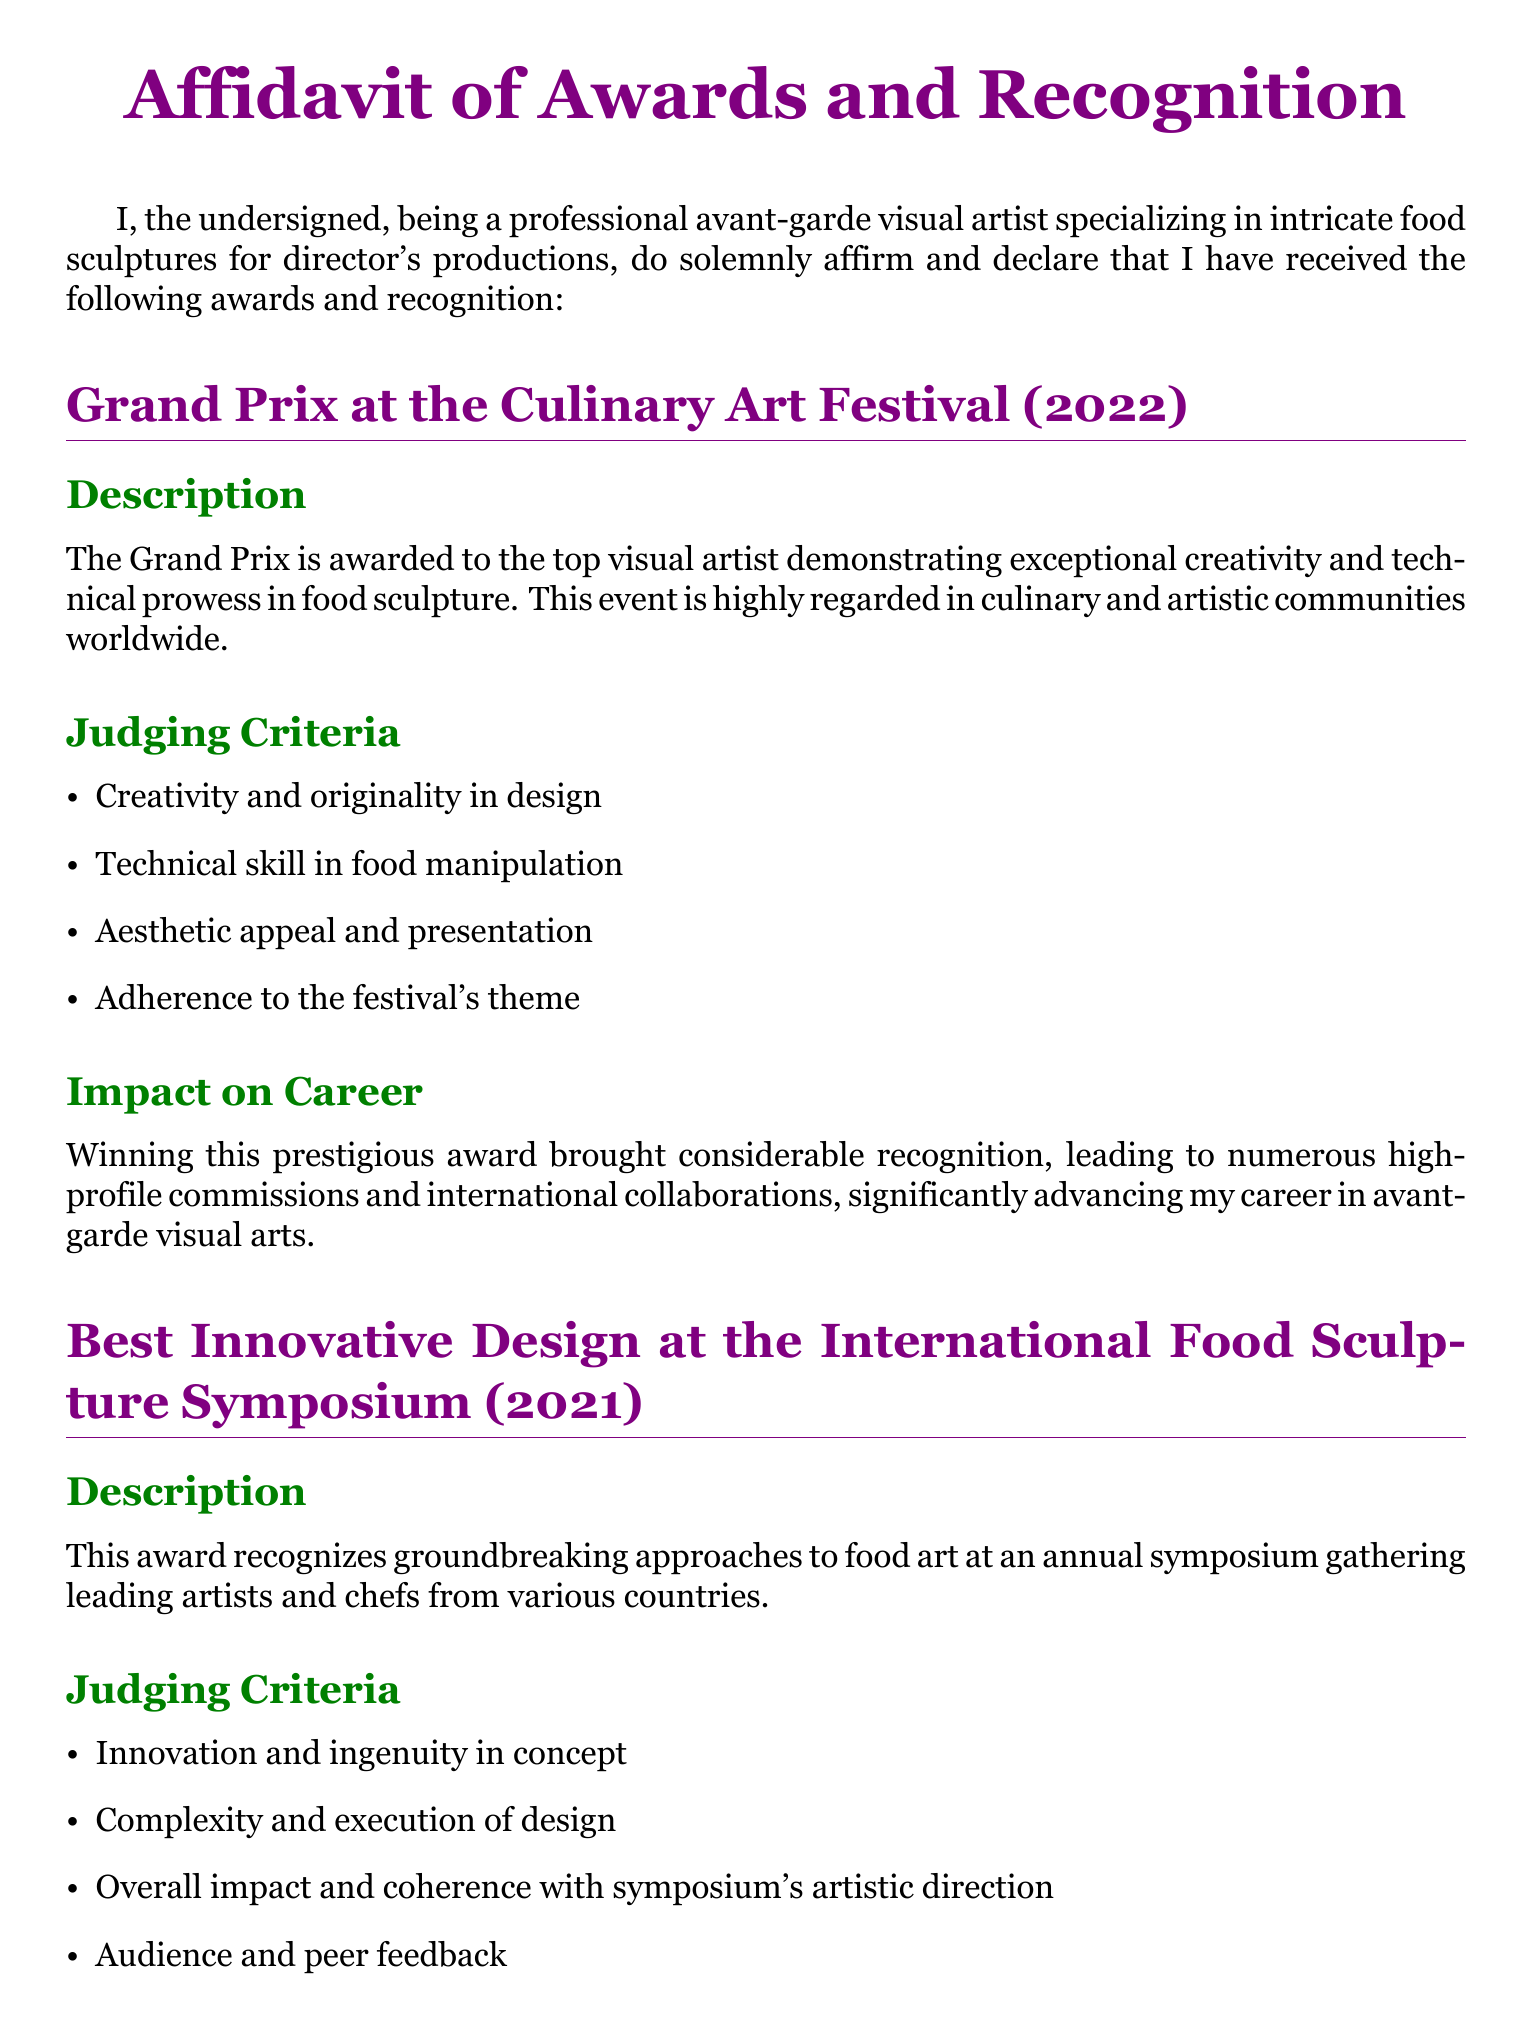What is the title of the affidavit? The title is found at the beginning of the document and indicates the subject matter of the declaration.
Answer: Affidavit of Awards and Recognition In which year did the artist win the Grand Prix at the Culinary Art Festival? The year is specified under the section detailing the award, indicating the date of the achievement.
Answer: 2022 What was the award received at the International Food Sculpture Symposium? The award name is clearly stated in the section covering the event and its significance.
Answer: Best Innovative Design Who awards the Critics' Choice Award at the Global Culinary Arts Expo? The awarding body is mentioned in the description of the Critics' Choice Award section, clarifying who provides this recognition.
Answer: Panel of esteemed culinary critics and art historians What criteria emphasizes originality in the Grand Prix judging? This criterion is outlined in the list of judging criteria under the Grand Prix section, highlighting its importance.
Answer: Creativity and originality in design How did winning the Grand Prix impact the artist's career? The impact of the award is described, reflecting on the broader implications of such recognition.
Answer: Considerable recognition, leading to numerous high-profile commissions Which award was given in 2021? The year corresponds to the event detailed before the award description, indicating when it was received.
Answer: Best Innovative Design at the International Food Sculpture Symposium What is one judging criterion for the Critics' Choice Award? The judging criteria are listed under the respective award, showcasing what the panel looks for.
Answer: Artistic expression and thematic clarity What is the document’s main profession of the undersigned? The profession is stated in the introduction, clarifying the expertise and focus of the individual.
Answer: Avant-garde visual artist specializing in intricate food sculptures 